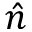Convert formula to latex. <formula><loc_0><loc_0><loc_500><loc_500>\hat { n }</formula> 